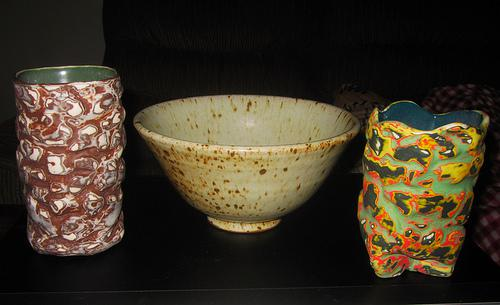Question: what are these?
Choices:
A. Cans.
B. Pots.
C. Forks.
D. Plates.
Answer with the letter. Answer: B Question: why are the pots painted?
Choices:
A. They were old.
B. For decoration.
C. For the show.
D. To match the house.
Answer with the letter. Answer: B Question: how many pots are there?
Choices:
A. Three.
B. Two.
C. One.
D. Four.
Answer with the letter. Answer: A Question: where is the biggest pot?
Choices:
A. On the porch.
B. In the yard.
C. In the house.
D. In the middle.
Answer with the letter. Answer: D 